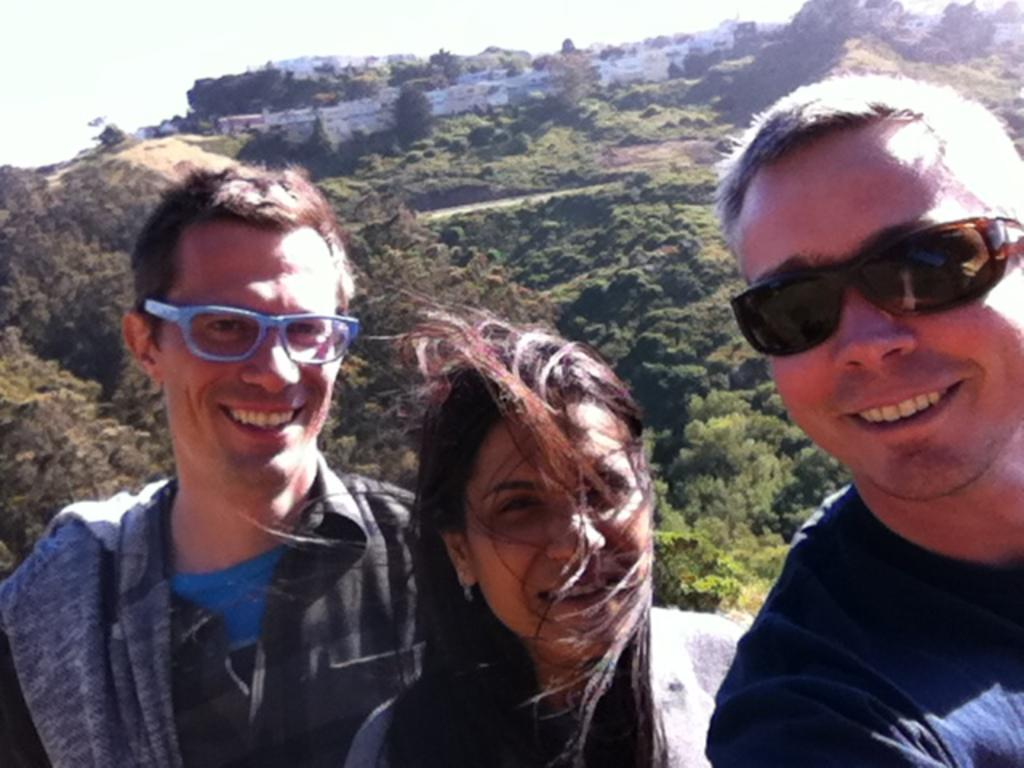How many persons are in the image? There are persons in the image. What are the persons doing in the image? The persons are laughing. What can be seen in the background of the image? There are trees, hills, buildings, and the sky visible in the background of the image. What type of pen is being used by the persons in the image? There is no pen present in the image; the persons are laughing and no writing instruments are visible. 